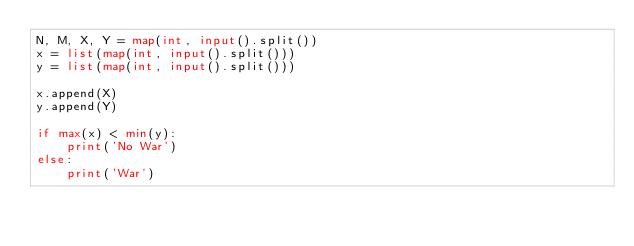Convert code to text. <code><loc_0><loc_0><loc_500><loc_500><_Python_>N, M, X, Y = map(int, input().split())
x = list(map(int, input().split()))
y = list(map(int, input().split()))

x.append(X)
y.append(Y)

if max(x) < min(y):
    print('No War')
else:
    print('War')</code> 